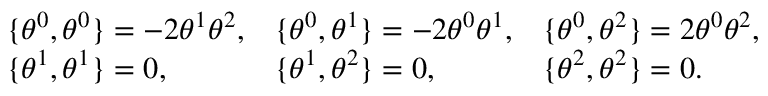<formula> <loc_0><loc_0><loc_500><loc_500>\begin{array} { l l l } { { \{ \theta ^ { 0 } , \theta ^ { 0 } \} = - 2 \theta ^ { 1 } \theta ^ { 2 } , } } & { { \{ \theta ^ { 0 } , \theta ^ { 1 } \} = - 2 \theta ^ { 0 } \theta ^ { 1 } , } } & { { \{ \theta ^ { 0 } , \theta ^ { 2 } \} = 2 \theta ^ { 0 } \theta ^ { 2 } , } } \\ { { \{ \theta ^ { 1 } , \theta ^ { 1 } \} = 0 , } } & { { \{ \theta ^ { 1 } , \theta ^ { 2 } \} = 0 , } } & { { \{ \theta ^ { 2 } , \theta ^ { 2 } \} = 0 . } } \end{array}</formula> 